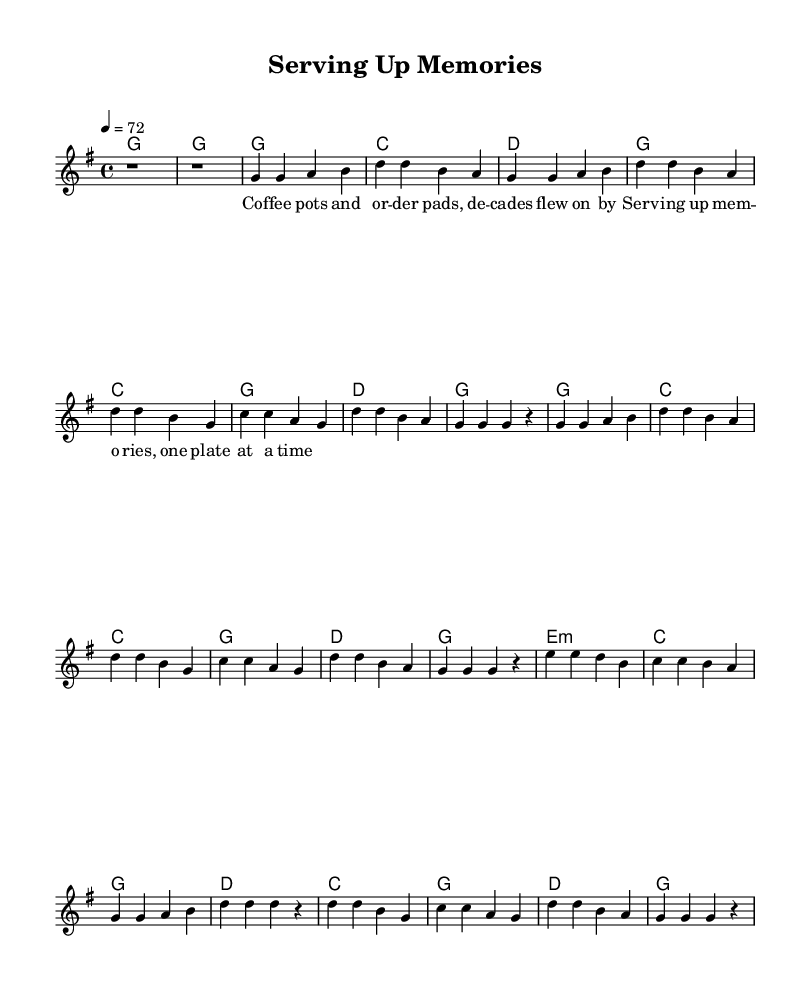What is the key signature of this music? The key signature is G major, indicated by one sharp (F#) at the beginning of the staff.
Answer: G major What is the time signature of this music? The time signature shown at the beginning is 4/4, meaning there are four beats in a measure and a quarter note receives one beat.
Answer: 4/4 What is the tempo marking for this piece? The tempo marking at the beginning states "4 = 72", indicating the quarter note should be played at a speed of 72 beats per minute.
Answer: 72 How many measures are there in the first verse? Counting the measures in Verse 1, there are a total of 4 measures. Each line of lyrics corresponds to a measure, and the notes indicate four separate measures.
Answer: 4 What is the last chord in the final chorus? The last chord of the final chorus is a G major, which is shown in the chord symbols above the melody. It concludes the piece with the tonic chord.
Answer: G Which section includes the bridge? The bridge section is indicated after the second chorus and is marked clearly in the sheet music. It has different melodic and harmonic material compared to the verses and choruses.
Answer: Bridge What lyrical theme is conveyed in the chorus? The chorus emphasizes nostalgia and memory tied to the waitressing experience, as articulated in the lyrics about "serving up memories." This creates an emotional connection to the life of a waitress.
Answer: Nostalgia 